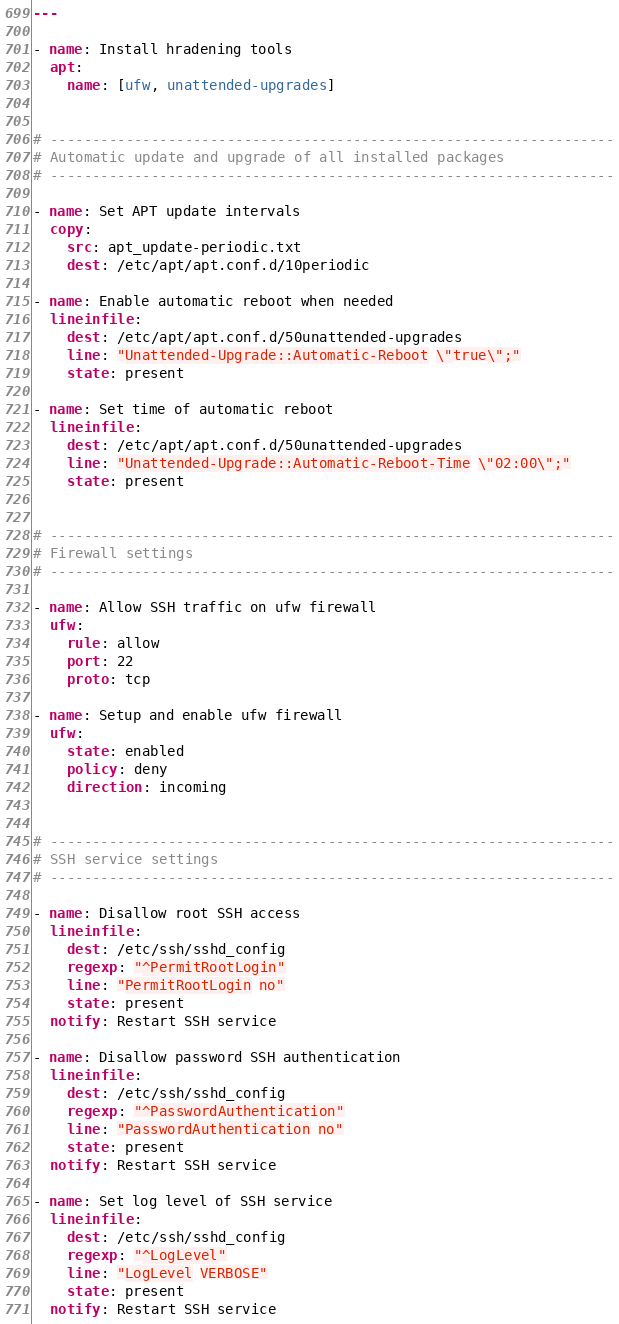Convert code to text. <code><loc_0><loc_0><loc_500><loc_500><_YAML_>---

- name: Install hradening tools
  apt:
    name: [ufw, unattended-upgrades]


# -------------------------------------------------------------------
# Automatic update and upgrade of all installed packages
# -------------------------------------------------------------------

- name: Set APT update intervals
  copy:
    src: apt_update-periodic.txt
    dest: /etc/apt/apt.conf.d/10periodic

- name: Enable automatic reboot when needed
  lineinfile:
    dest: /etc/apt/apt.conf.d/50unattended-upgrades
    line: "Unattended-Upgrade::Automatic-Reboot \"true\";"
    state: present

- name: Set time of automatic reboot
  lineinfile:
    dest: /etc/apt/apt.conf.d/50unattended-upgrades
    line: "Unattended-Upgrade::Automatic-Reboot-Time \"02:00\";"
    state: present


# -------------------------------------------------------------------
# Firewall settings
# -------------------------------------------------------------------

- name: Allow SSH traffic on ufw firewall
  ufw:
    rule: allow
    port: 22
    proto: tcp

- name: Setup and enable ufw firewall
  ufw:
    state: enabled
    policy: deny
    direction: incoming


# -------------------------------------------------------------------
# SSH service settings
# -------------------------------------------------------------------

- name: Disallow root SSH access
  lineinfile:
    dest: /etc/ssh/sshd_config
    regexp: "^PermitRootLogin"
    line: "PermitRootLogin no"
    state: present
  notify: Restart SSH service

- name: Disallow password SSH authentication
  lineinfile:
    dest: /etc/ssh/sshd_config
    regexp: "^PasswordAuthentication"
    line: "PasswordAuthentication no"
    state: present
  notify: Restart SSH service

- name: Set log level of SSH service
  lineinfile:
    dest: /etc/ssh/sshd_config
    regexp: "^LogLevel"
    line: "LogLevel VERBOSE"
    state: present
  notify: Restart SSH service
</code> 